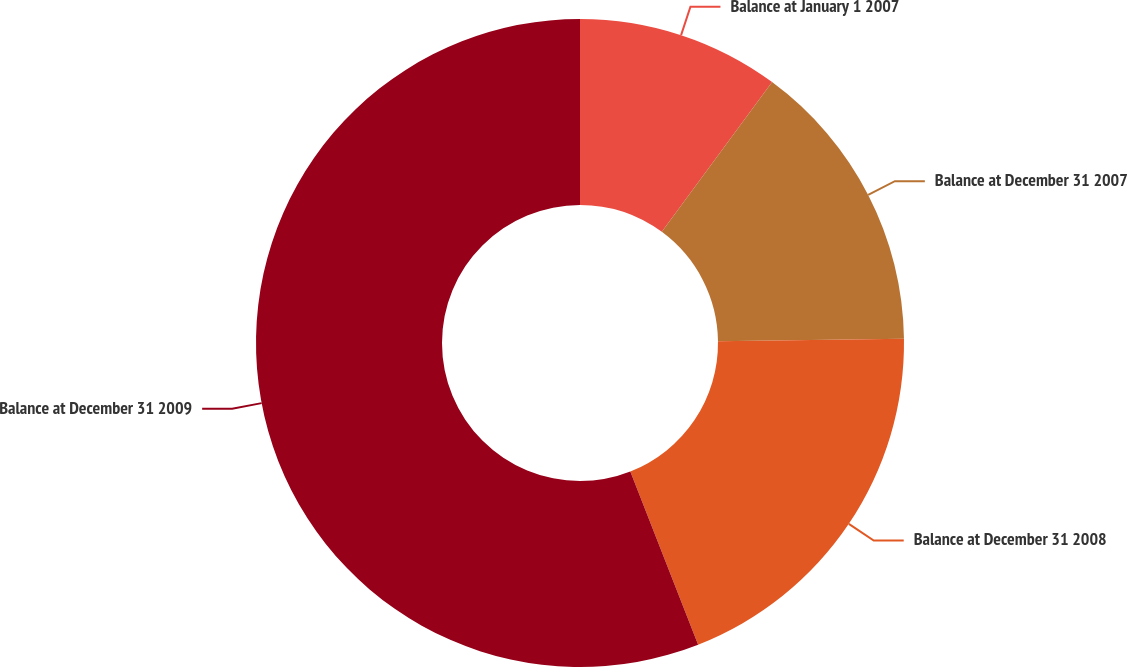Convert chart. <chart><loc_0><loc_0><loc_500><loc_500><pie_chart><fcel>Balance at January 1 2007<fcel>Balance at December 31 2007<fcel>Balance at December 31 2008<fcel>Balance at December 31 2009<nl><fcel>10.1%<fcel>14.69%<fcel>19.27%<fcel>55.94%<nl></chart> 